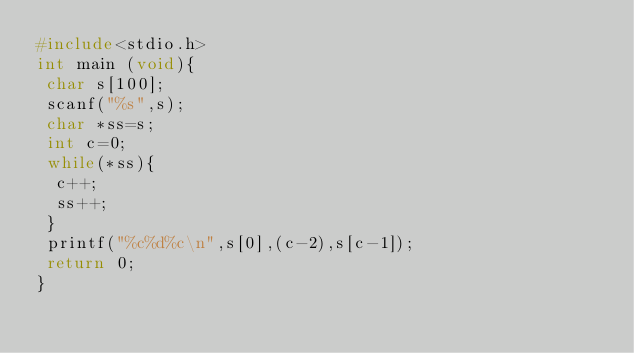Convert code to text. <code><loc_0><loc_0><loc_500><loc_500><_C_>#include<stdio.h>
int main (void){
 char s[100];
 scanf("%s",s);
 char *ss=s;
 int c=0;
 while(*ss){
  c++;
  ss++;
 }
 printf("%c%d%c\n",s[0],(c-2),s[c-1]);
 return 0;
}
</code> 